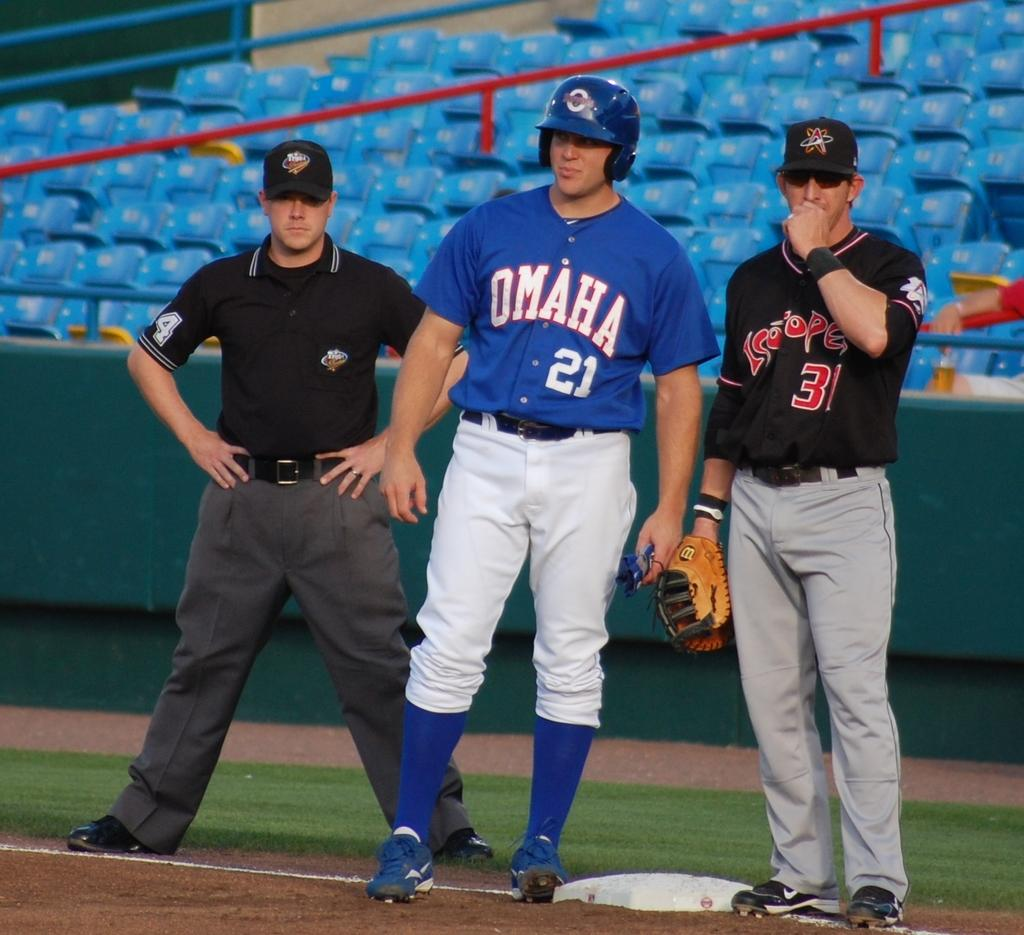<image>
Create a compact narrative representing the image presented. Baseball player on base with a blue uniform shirt that has Omaha on it. 